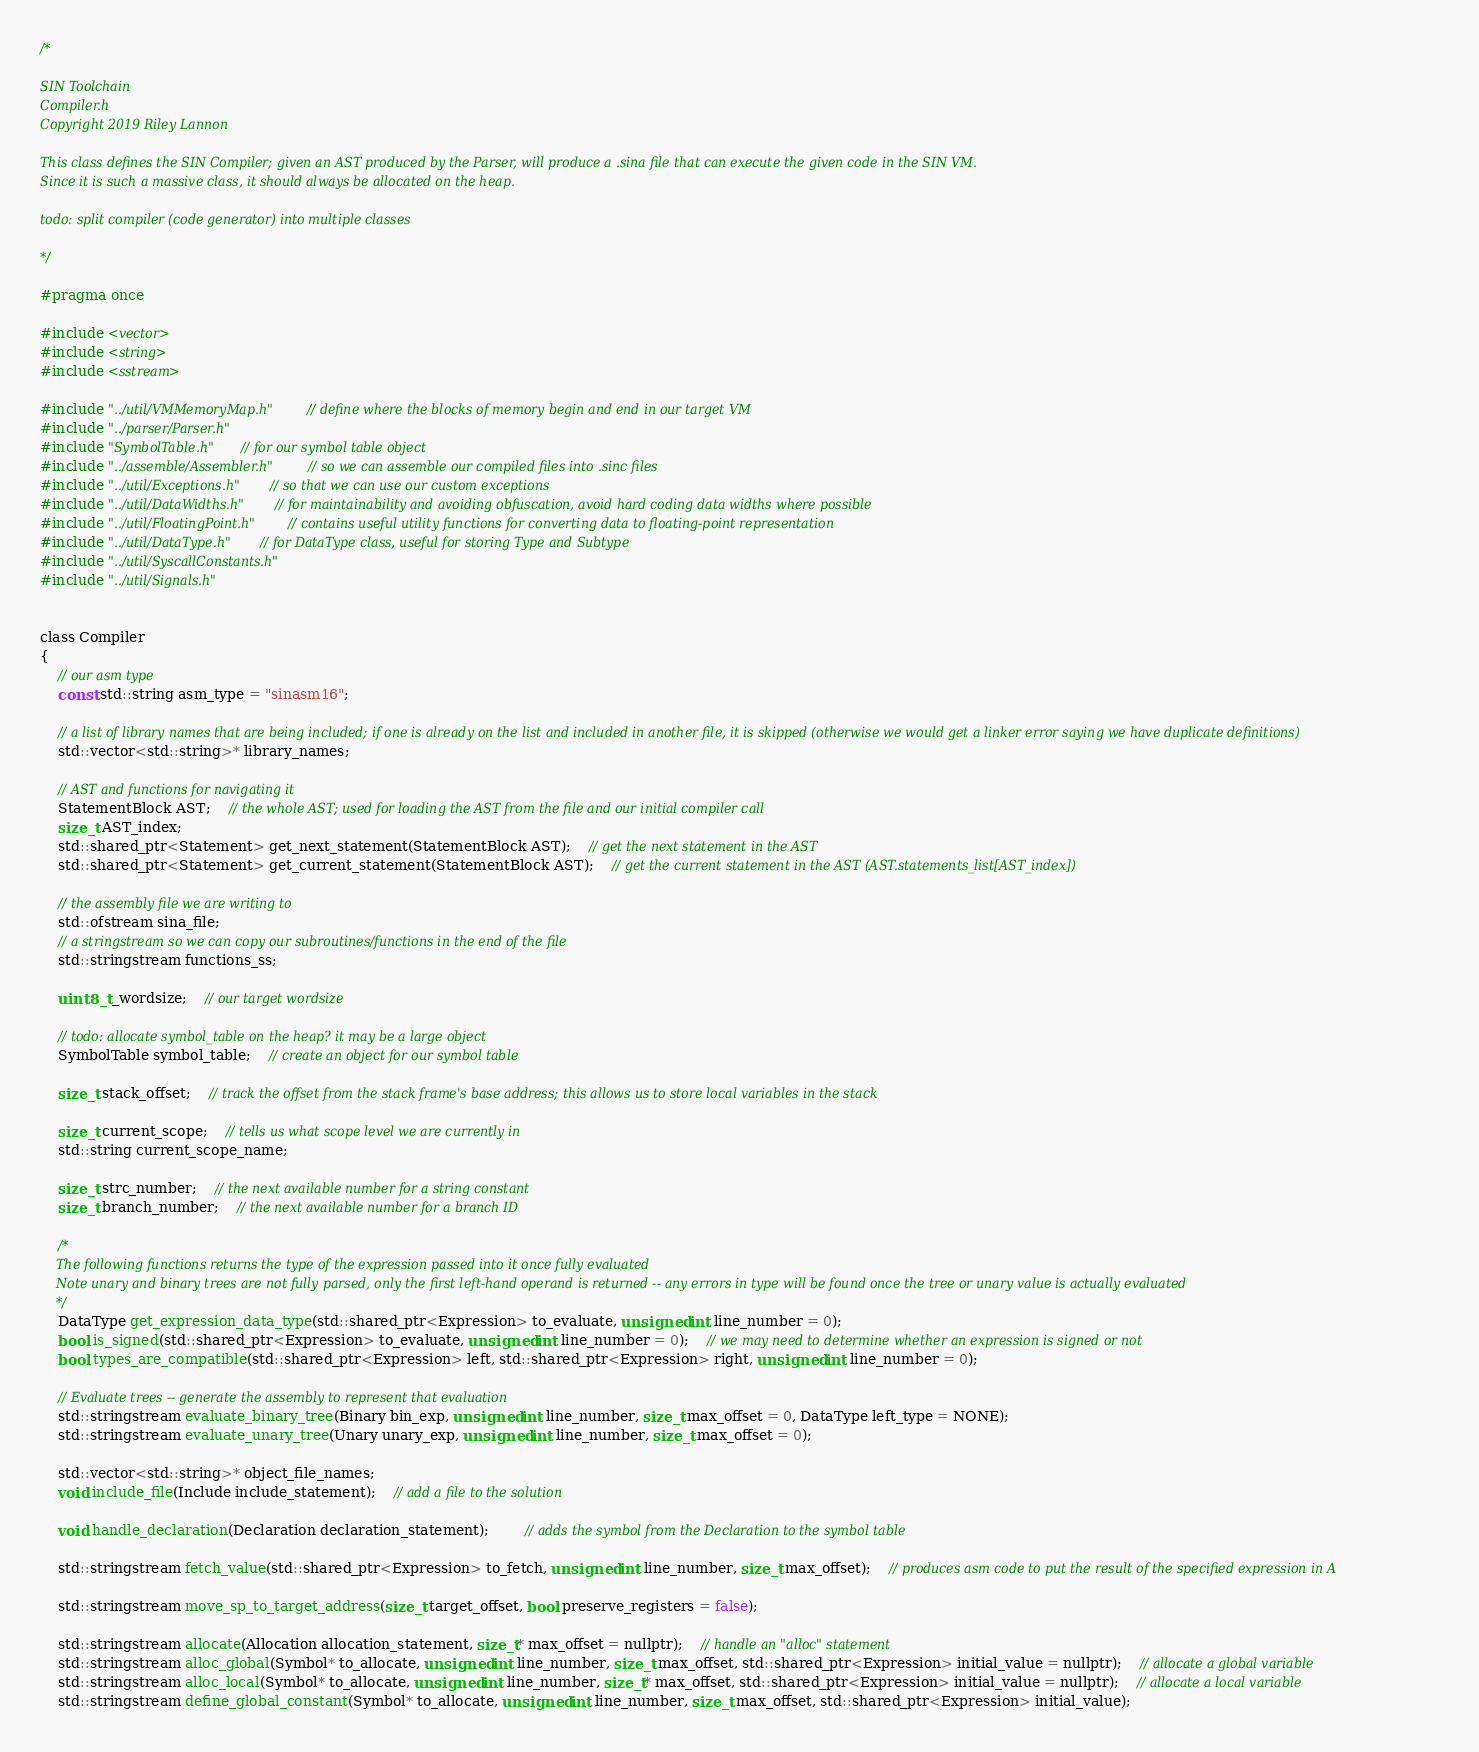Convert code to text. <code><loc_0><loc_0><loc_500><loc_500><_C_>/*

SIN Toolchain
Compiler.h
Copyright 2019 Riley Lannon

This class defines the SIN Compiler; given an AST produced by the Parser, will produce a .sina file that can execute the given code in the SIN VM.
Since it is such a massive class, it should always be allocated on the heap.

todo: split compiler (code generator) into multiple classes

*/

#pragma once

#include <vector>
#include <string>
#include <sstream>

#include "../util/VMMemoryMap.h"	// define where the blocks of memory begin and end in our target VM
#include "../parser/Parser.h"
#include "SymbolTable.h"	// for our symbol table object
#include "../assemble/Assembler.h"	// so we can assemble our compiled files into .sinc files
#include "../util/Exceptions.h"	// so that we can use our custom exceptions
#include "../util/DataWidths.h"	// for maintainability and avoiding obfuscation, avoid hard coding data widths where possible
#include "../util/FloatingPoint.h"	// contains useful utility functions for converting data to floating-point representation
#include "../util/DataType.h"	// for DataType class, useful for storing Type and Subtype
#include "../util/SyscallConstants.h"
#include "../util/Signals.h"


class Compiler
{
	// our asm type
	const std::string asm_type = "sinasm16";

	// a list of library names that are being included; if one is already on the list and included in another file, it is skipped (otherwise we would get a linker error saying we have duplicate definitions)
	std::vector<std::string>* library_names;

	// AST and functions for navigating it
	StatementBlock AST;	// the whole AST; used for loading the AST from the file and our initial compiler call
	size_t AST_index;
	std::shared_ptr<Statement> get_next_statement(StatementBlock AST);	// get the next statement in the AST
	std::shared_ptr<Statement> get_current_statement(StatementBlock AST);	// get the current statement in the AST (AST.statements_list[AST_index])
	
	// the assembly file we are writing to
	std::ofstream sina_file;
	// a stringstream so we can copy our subroutines/functions in the end of the file
	std::stringstream functions_ss;

	uint8_t _wordsize;	// our target wordsize

	// todo: allocate symbol_table on the heap? it may be a large object
	SymbolTable symbol_table;	// create an object for our symbol table

	size_t stack_offset;	// track the offset from the stack frame's base address; this allows us to store local variables in the stack

	size_t current_scope;	// tells us what scope level we are currently in
	std::string current_scope_name;

	size_t strc_number;	// the next available number for a string constant
	size_t branch_number;	// the next available number for a branch ID

	/* 
	The following functions returns the type of the expression passed into it once fully evaluated
	Note unary and binary trees are not fully parsed, only the first left-hand operand is returned -- any errors in type will be found once the tree or unary value is actually evaluated
	*/
	DataType get_expression_data_type(std::shared_ptr<Expression> to_evaluate, unsigned int line_number = 0);
	bool is_signed(std::shared_ptr<Expression> to_evaluate, unsigned int line_number = 0);	// we may need to determine whether an expression is signed or not
	bool types_are_compatible(std::shared_ptr<Expression> left, std::shared_ptr<Expression> right, unsigned int line_number = 0);

	// Evaluate trees -- generate the assembly to represent that evaluation
	std::stringstream evaluate_binary_tree(Binary bin_exp, unsigned int line_number, size_t max_offset = 0, DataType left_type = NONE);
	std::stringstream evaluate_unary_tree(Unary unary_exp, unsigned int line_number, size_t max_offset = 0);

	std::vector<std::string>* object_file_names;
	void include_file(Include include_statement);	// add a file to the solution

	void handle_declaration(Declaration declaration_statement);		// adds the symbol from the Declaration to the symbol table

	std::stringstream fetch_value(std::shared_ptr<Expression> to_fetch, unsigned int line_number, size_t max_offset);	// produces asm code to put the result of the specified expression in A

	std::stringstream move_sp_to_target_address(size_t target_offset, bool preserve_registers = false);

	std::stringstream allocate(Allocation allocation_statement, size_t* max_offset = nullptr);	// handle an "alloc" statement
	std::stringstream alloc_global(Symbol* to_allocate, unsigned int line_number, size_t max_offset, std::shared_ptr<Expression> initial_value = nullptr);	// allocate a global variable
	std::stringstream alloc_local(Symbol* to_allocate, unsigned int line_number, size_t* max_offset, std::shared_ptr<Expression> initial_value = nullptr);	// allocate a local variable
	std::stringstream define_global_constant(Symbol* to_allocate, unsigned int line_number, size_t max_offset, std::shared_ptr<Expression> initial_value);
</code> 